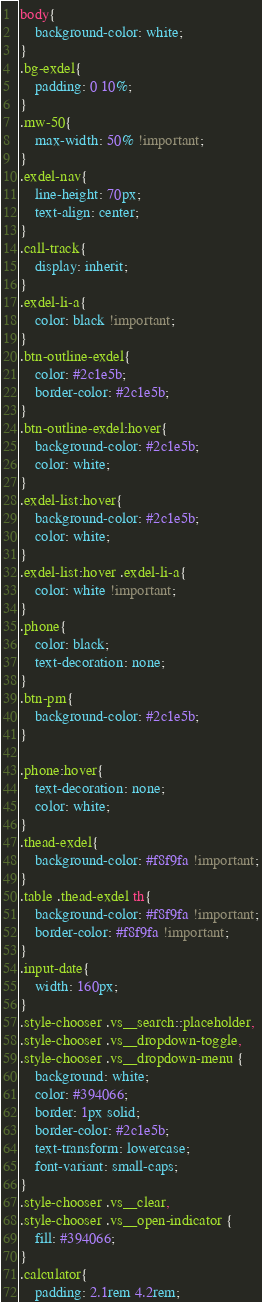<code> <loc_0><loc_0><loc_500><loc_500><_CSS_>body{
    background-color: white;
}
.bg-exdel{
    padding: 0 10%;
}
.mw-50{
    max-width: 50% !important;
}
.exdel-nav{
    line-height: 70px;
    text-align: center;
}
.call-track{
    display: inherit;
}
.exdel-li-a{
    color: black !important;
}
.btn-outline-exdel{
    color: #2c1e5b;
    border-color: #2c1e5b;
}
.btn-outline-exdel:hover{
    background-color: #2c1e5b;
    color: white;
}
.exdel-list:hover{
    background-color: #2c1e5b;
    color: white;
}
.exdel-list:hover .exdel-li-a{
    color: white !important;
}
.phone{
    color: black;
    text-decoration: none;
}
.btn-pm{
    background-color: #2c1e5b;
}

.phone:hover{
    text-decoration: none;
    color: white;
}
.thead-exdel{
    background-color: #f8f9fa !important;
}
.table .thead-exdel th{
    background-color: #f8f9fa !important;
    border-color: #f8f9fa !important;
}
.input-date{
    width: 160px;
}
.style-chooser .vs__search::placeholder,
.style-chooser .vs__dropdown-toggle,
.style-chooser .vs__dropdown-menu {
    background: white;
    color: #394066;
    border: 1px solid;
    border-color: #2c1e5b;
    text-transform: lowercase;
    font-variant: small-caps;
}
.style-chooser .vs__clear,
.style-chooser .vs__open-indicator {
    fill: #394066;
}
.calculator{
    padding: 2.1rem 4.2rem;</code> 